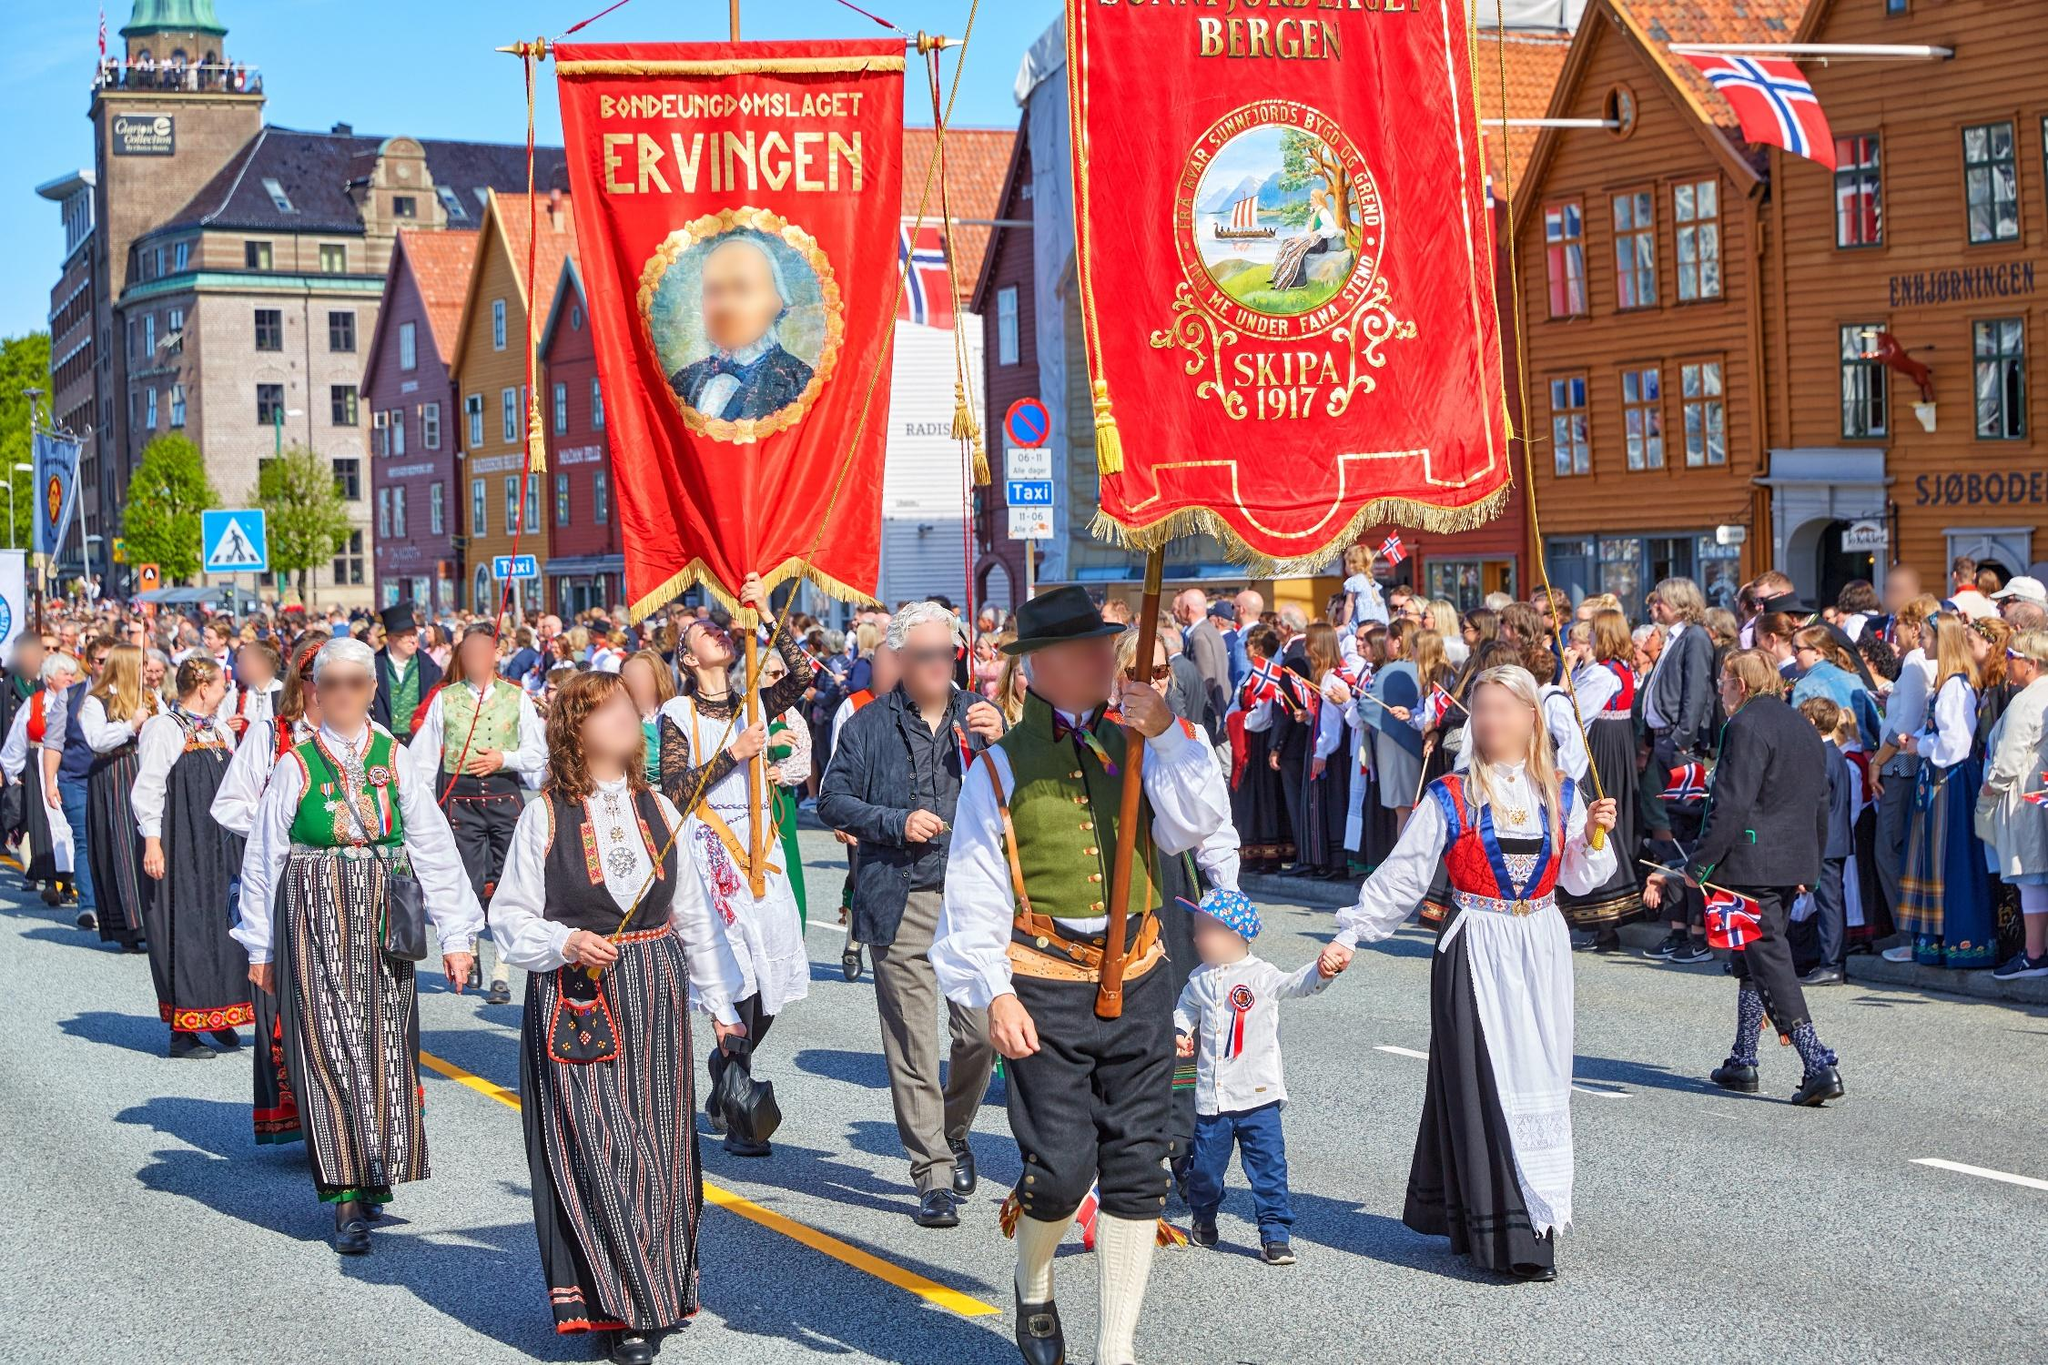Can you tell me more about the traditional clothing worn by participants in the parade? The traditional clothing worn by the participants is known as bunad, a type of Norwegian folk costume that varies by region. These costumes are highly detailed and typically include embroidered woolen garments, silver jewelry, and distinctive headwear. The bunads worn in the parade showcase intricate patterns and vibrant colors, reflecting the rich cultural heritage of Norway. Women are often seen in long skirts with detailed aprons and bodices, while men might wear embroidered vests, knee-britches, and woolen stockings. Each bunad tells a story of the region it originates from, making them not only beautiful garments but also cultural artifacts. 